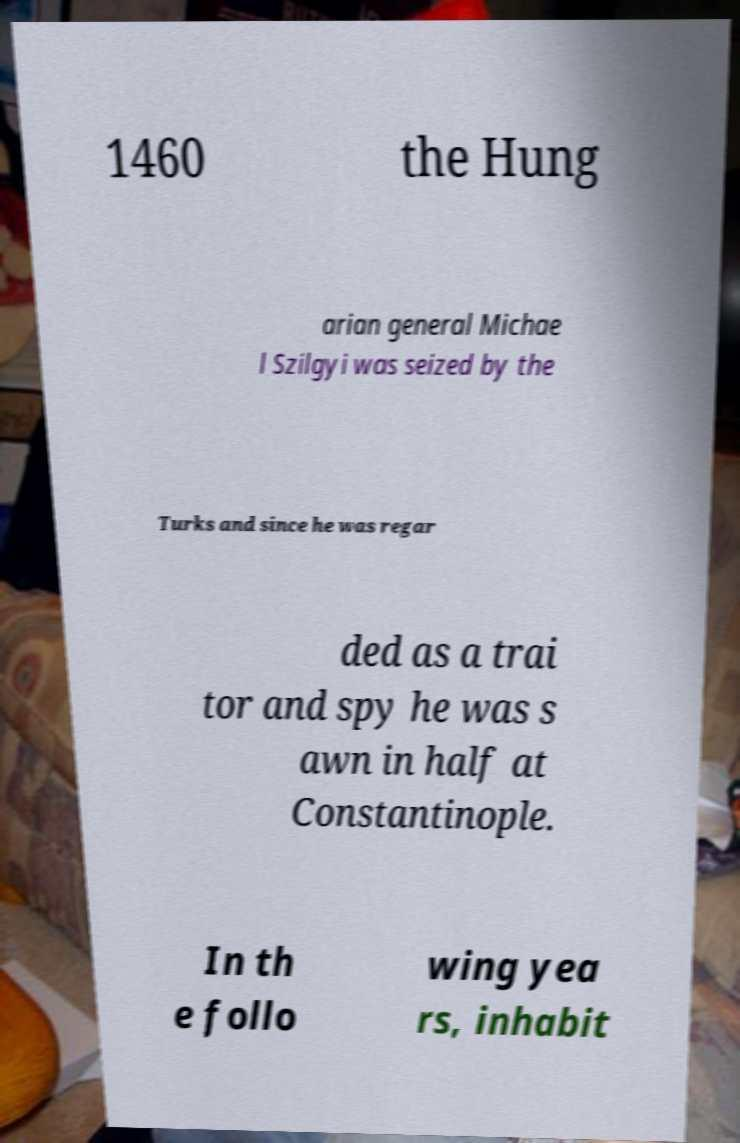Please read and relay the text visible in this image. What does it say? 1460 the Hung arian general Michae l Szilgyi was seized by the Turks and since he was regar ded as a trai tor and spy he was s awn in half at Constantinople. In th e follo wing yea rs, inhabit 